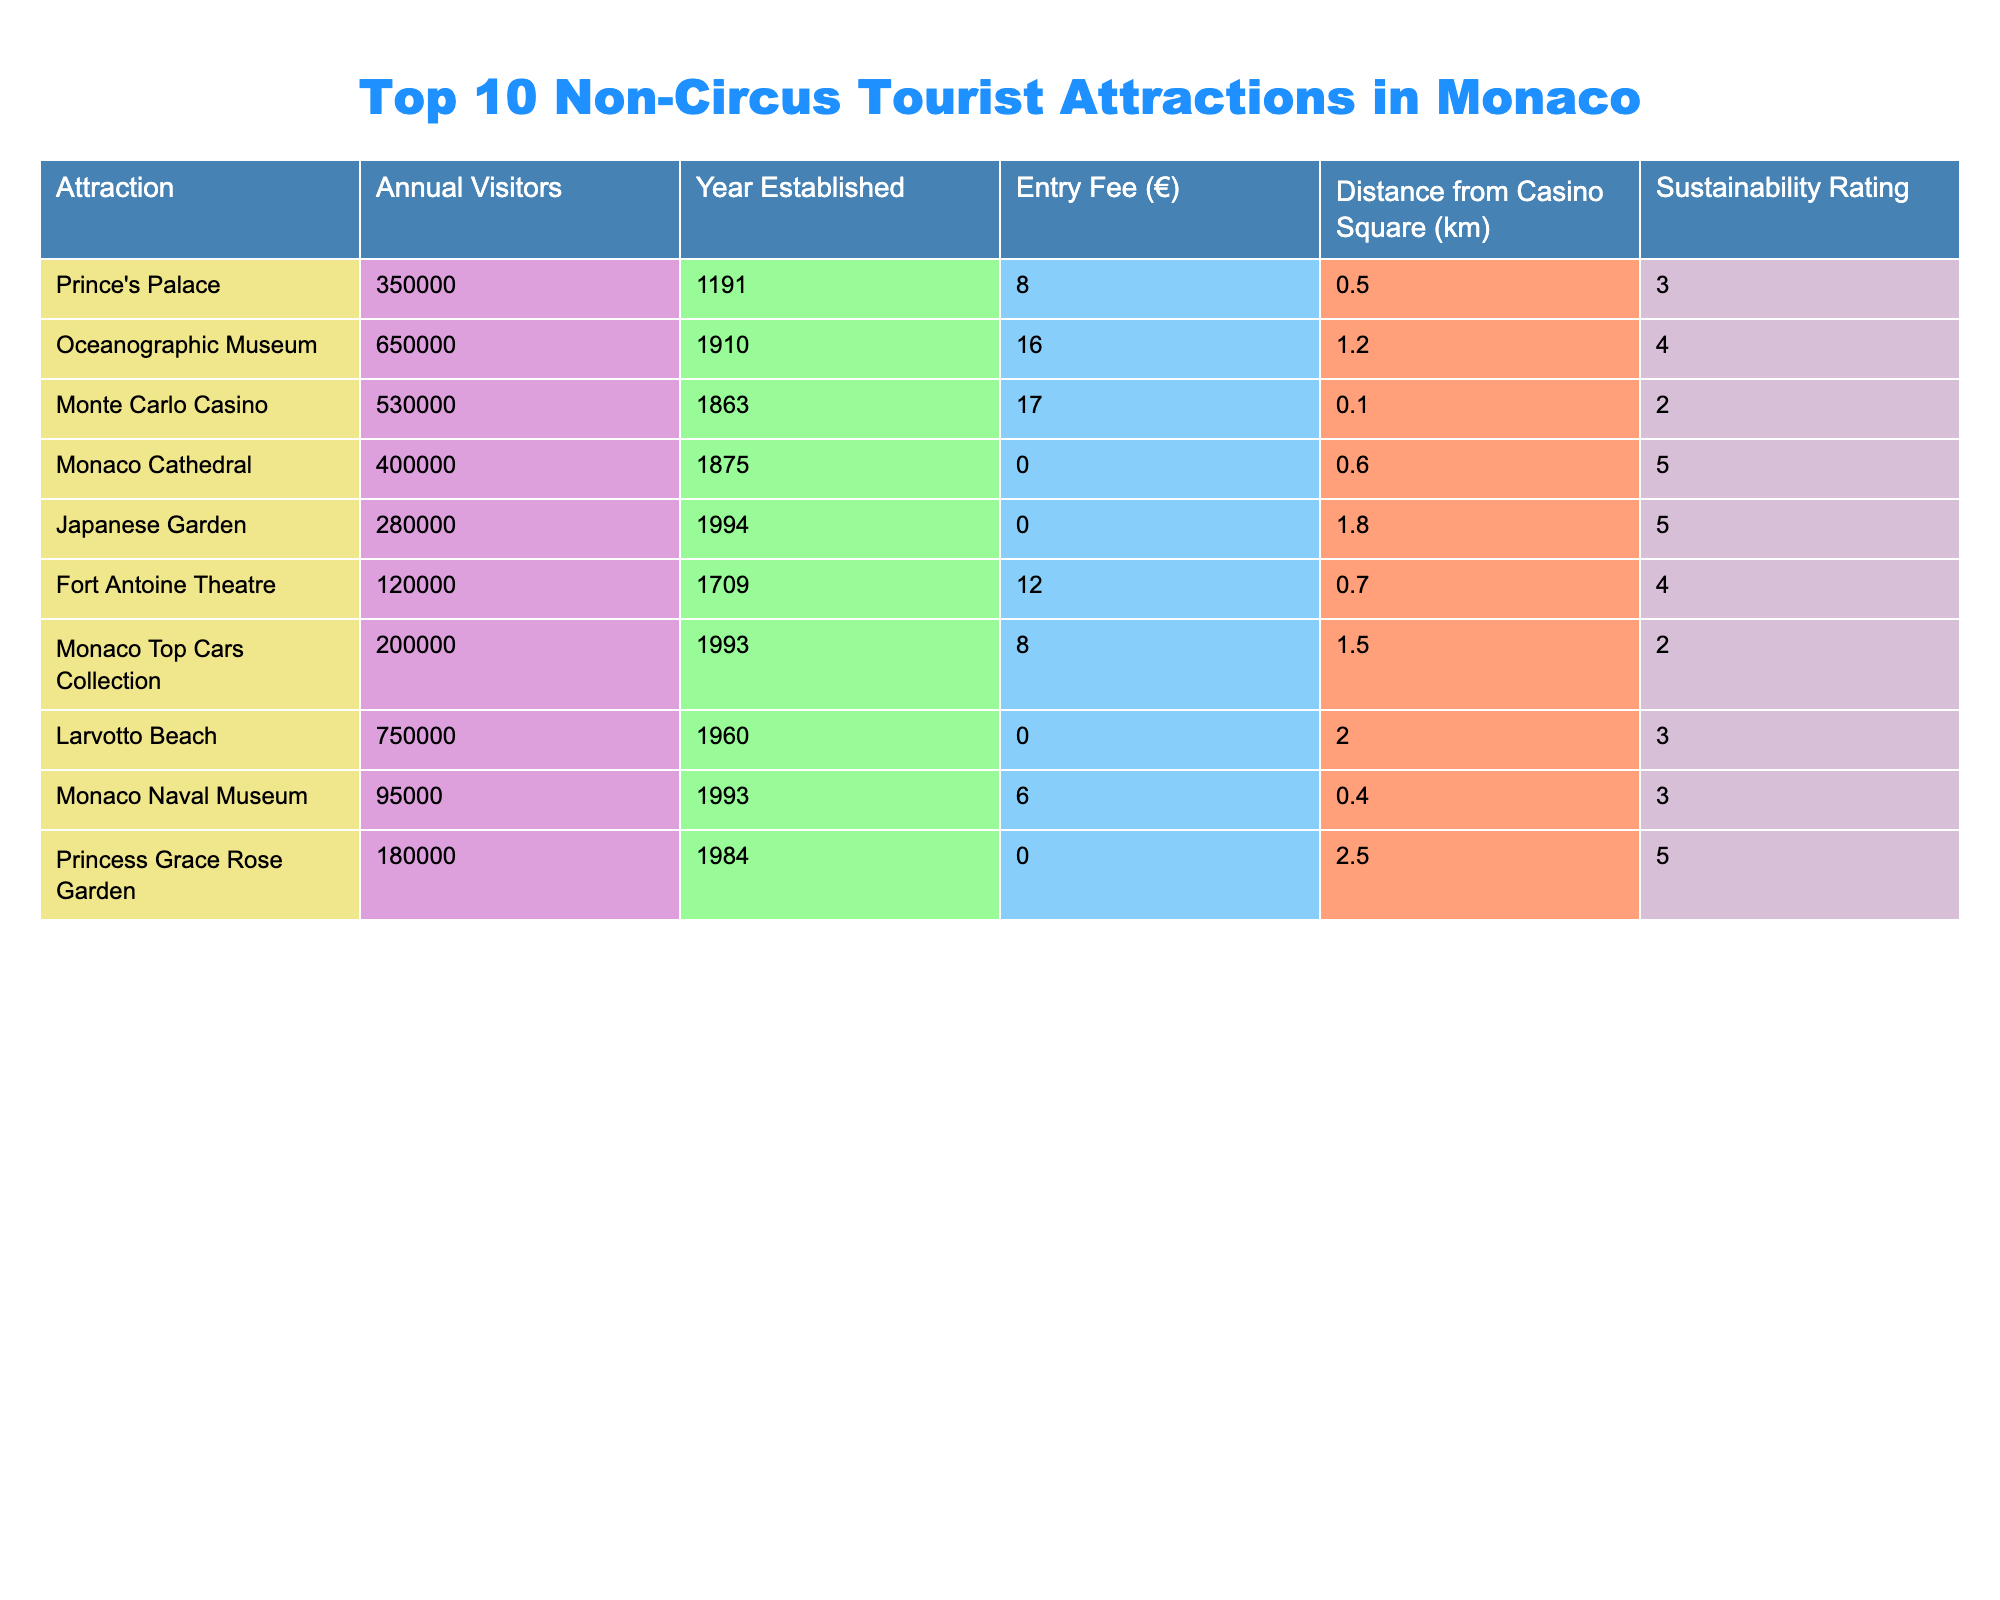What is the attraction with the most annual visitors? The table shows that the Oceanographic Museum has the highest number of annual visitors at 650,000.
Answer: Oceanographic Museum What is the entry fee for Monaco Cathedral? The table indicates that the entry fee for Monaco Cathedral is €0.
Answer: 0 Which two attractions are free to enter? By examining the entry fee column, we see that both Monaco Cathedral and Japanese Garden have an entry fee of €0, which makes them free to enter.
Answer: Monaco Cathedral and Japanese Garden What is the average number of annual visitors for the top three attractions listed? Adding the annual visitors for the top three attractions: 350,000 + 650,000 + 530,000 = 1,530,000. Then dividing by 3 gives an average of 1,530,000 / 3 = 510,000.
Answer: 510,000 Is the Princess Grace Rose Garden more sustainable than the Fort Antoine Theatre? Princess Grace Rose Garden has a sustainability rating of 5, while Fort Antoine Theatre has a rating of 4. Thus, the Rose Garden is more sustainable.
Answer: Yes How far is the nearest attraction to the Casino Square? The table shows that the Monte Carlo Casino is only 0.1 km away from the Casino Square, making it the nearest attraction.
Answer: 0.1 km What is the difference in annual visitors between Larvotto Beach and the Monaco Naval Museum? Larvotto Beach has 750,000 annual visitors, and the Monaco Naval Museum has 95,000. The difference is 750,000 - 95,000 = 655,000.
Answer: 655,000 Which attraction was established the earliest and what year was it? According to the year established column, the Prince's Palace was established in 1191, making it the earliest attraction listed.
Answer: 1191 Is the Oceanographic Museum's entry fee higher than that of the Monaco Top Cars Collection? The Oceanographic Museum has an entry fee of €16, while the Monaco Top Cars Collection has an entry fee of €8, which means the Oceanographic Museum is more expensive.
Answer: Yes What is the total number of annual visitors for attractions established after 1950? Adding the annual visitors: Larvotto Beach (750,000), Japanese Garden (280,000), and Monaco Top Cars Collection (200,000), the total is 750,000 + 280,000 + 200,000 = 1,230,000.
Answer: 1,230,000 